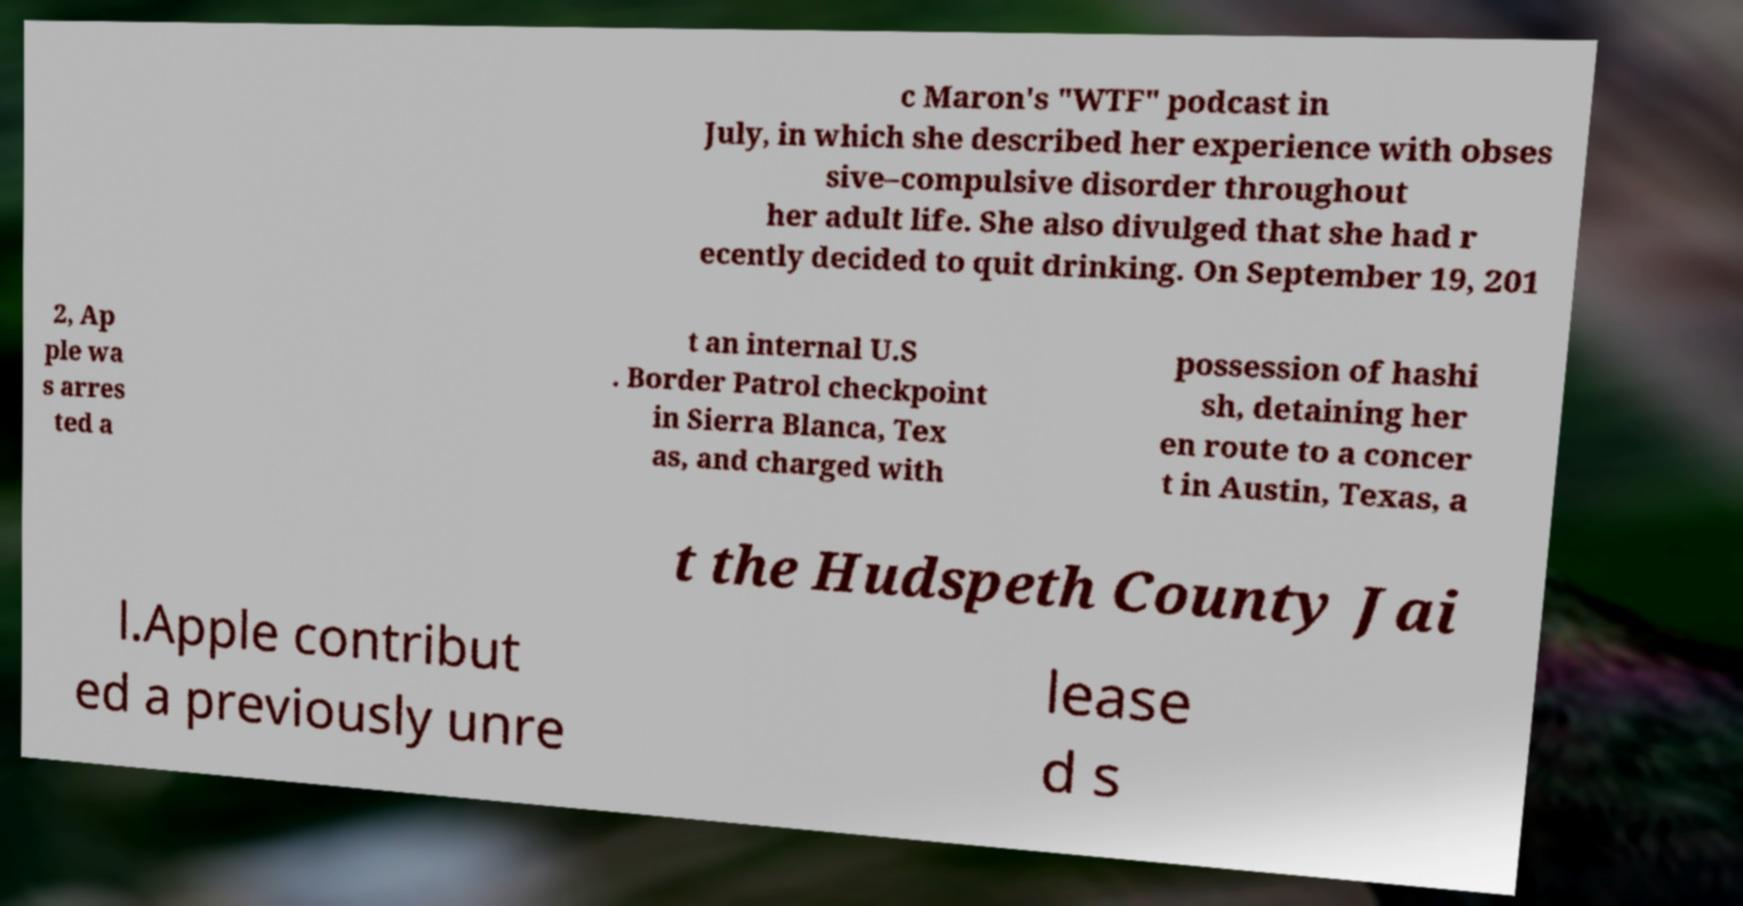For documentation purposes, I need the text within this image transcribed. Could you provide that? c Maron's "WTF" podcast in July, in which she described her experience with obses sive–compulsive disorder throughout her adult life. She also divulged that she had r ecently decided to quit drinking. On September 19, 201 2, Ap ple wa s arres ted a t an internal U.S . Border Patrol checkpoint in Sierra Blanca, Tex as, and charged with possession of hashi sh, detaining her en route to a concer t in Austin, Texas, a t the Hudspeth County Jai l.Apple contribut ed a previously unre lease d s 